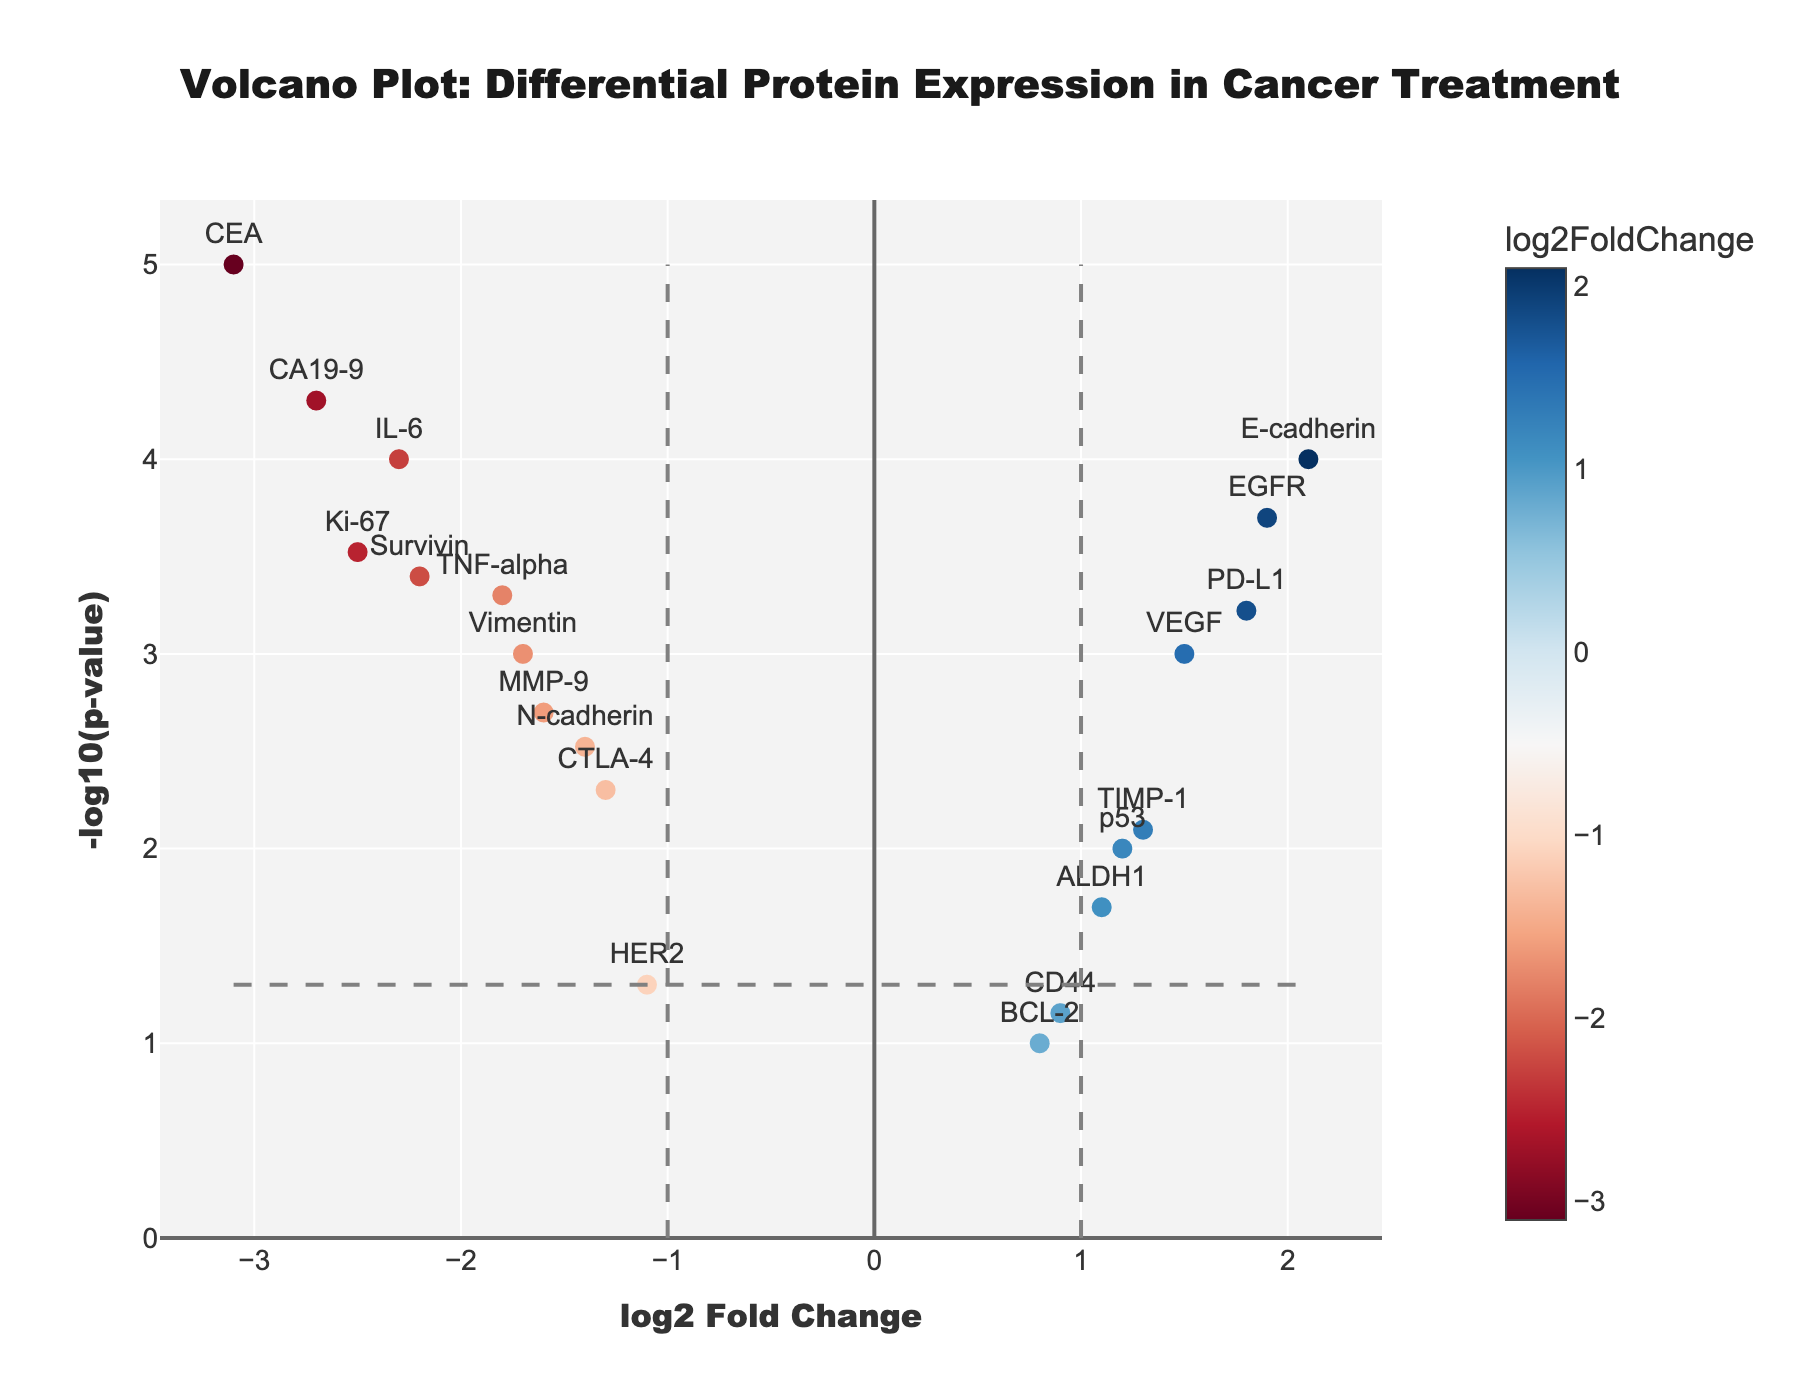How many proteins are represented in the plot? Count the number of distinct markers (points) in the plot.
Answer: 20 What are the axes labeled in the volcano plot? The x-axis label can be found at the bottom of the plot and the y-axis label is on the left side of the plot.
Answer: log2 Fold Change (x-axis), -log10(p-value) (y-axis) Which protein shows the highest log2 Fold Change? Identify the protein label at the far right end of the x-axis.
Answer: E-cadherin Which protein has the smallest p-value? The smallest p-value will correspond to the highest -log10(p-value) value on the y-axis. Look for the highest data point and check its label.
Answer: CEA How many proteins are significantly downregulated (log2 Fold Change < -1 and p-value < 0.05)? Count the data points that lie to the left of the vertical line at log2 Fold Change = -1 and above the horizontal line at -log10(p-value) corresponding to 0.05.
Answer: 7 Which proteins show a significant log2 Fold Change greater than 2? Look for the data points to the right of the vertical line at log2 Fold Change = 2.
Answer: E-cadherin Compare VEGF and Ki-67 in terms of log2 Fold Change and significance. Which one is more downregulated and more significant? Check the values for VEGF and Ki-67 and determine which has a lower log2 Fold Change and higher -log10(p-value).
Answer: Ki-67 Which protein has a log2 Fold Change closest to 0 but is still statistically significant (p-value < 0.05)? Look for the data point near log2 Fold Change = 0 and check if its -log10(p-value) is above the horizontal line at 0.05.
Answer: ALDH1 Identify the proteins with a log2 Fold Change greater than 1 and a p-value less than 0.001. Find the data points to the right of the vertical line at log2 Fold Change = 1 and above the horizontal line at -log10(p-value) corresponding to 0.001.
Answer: EGFR, E-cadherin 